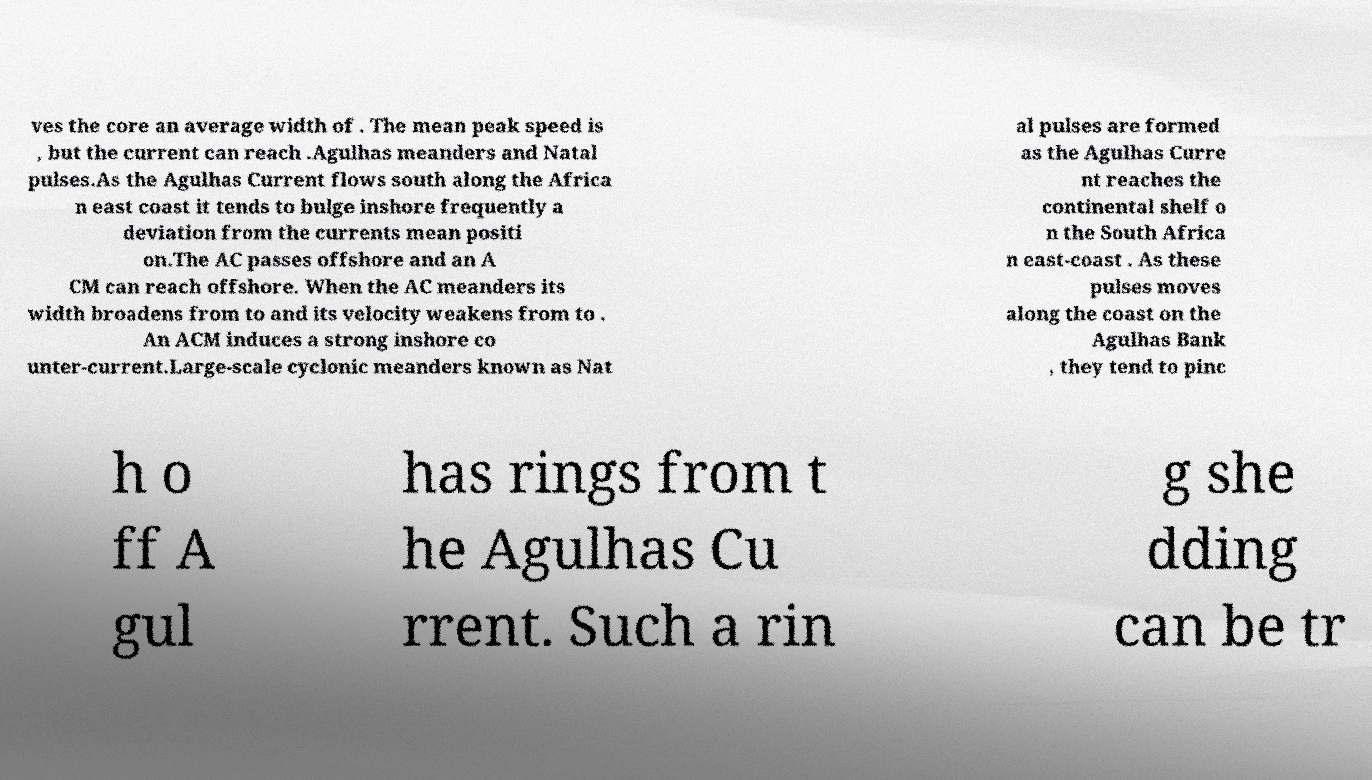What messages or text are displayed in this image? I need them in a readable, typed format. ves the core an average width of . The mean peak speed is , but the current can reach .Agulhas meanders and Natal pulses.As the Agulhas Current flows south along the Africa n east coast it tends to bulge inshore frequently a deviation from the currents mean positi on.The AC passes offshore and an A CM can reach offshore. When the AC meanders its width broadens from to and its velocity weakens from to . An ACM induces a strong inshore co unter-current.Large-scale cyclonic meanders known as Nat al pulses are formed as the Agulhas Curre nt reaches the continental shelf o n the South Africa n east-coast . As these pulses moves along the coast on the Agulhas Bank , they tend to pinc h o ff A gul has rings from t he Agulhas Cu rrent. Such a rin g she dding can be tr 